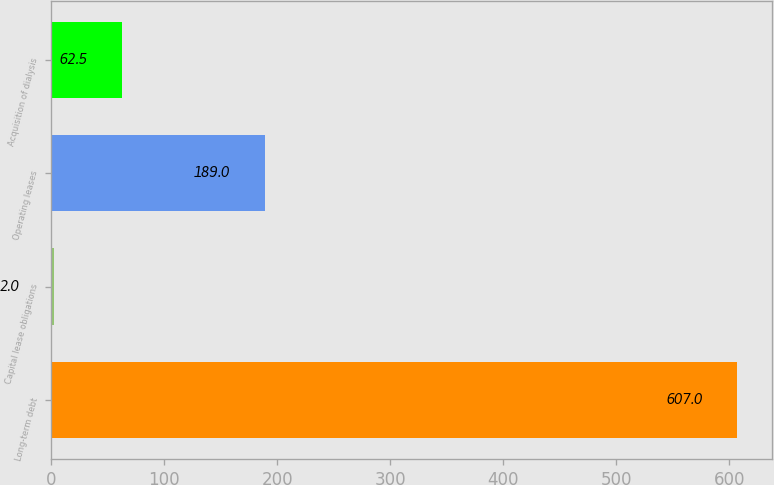Convert chart. <chart><loc_0><loc_0><loc_500><loc_500><bar_chart><fcel>Long-term debt<fcel>Capital lease obligations<fcel>Operating leases<fcel>Acquisition of dialysis<nl><fcel>607<fcel>2<fcel>189<fcel>62.5<nl></chart> 